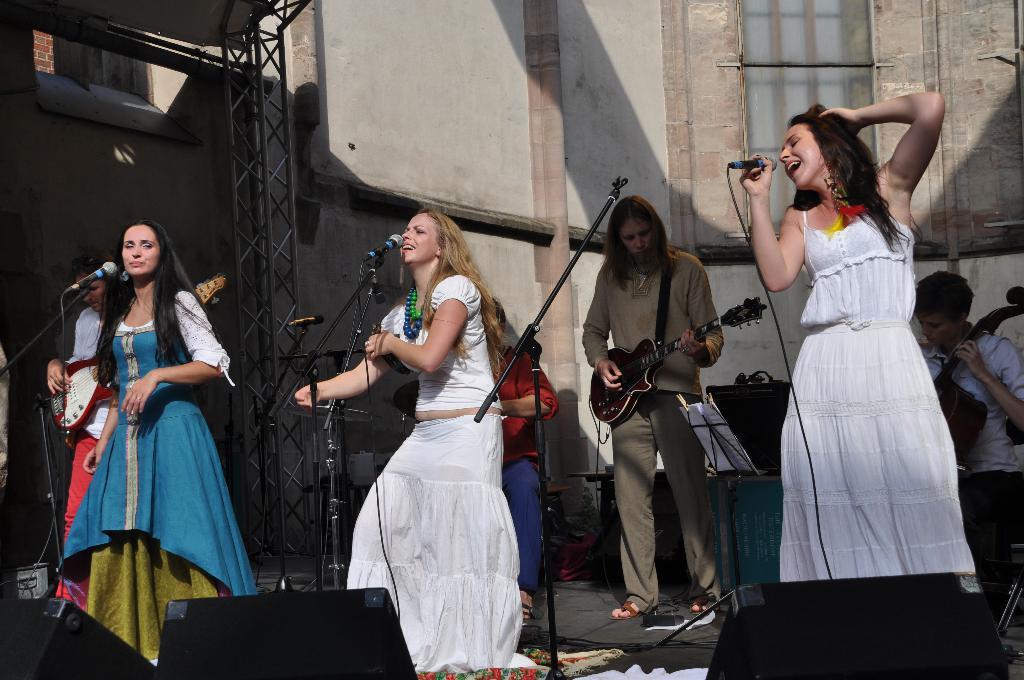Could you give a brief overview of what you see in this image? In this image we can see people standing and some of them are playing musical instruments. In the background there is a band. At the bottom there are speakers. We can see a wall and a window. There are mics placed on the stands. 